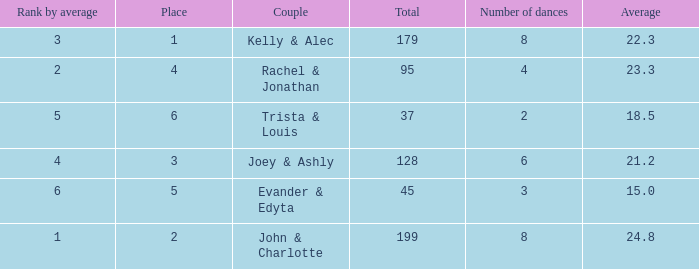What is the highest average that has 6 dances and a total of over 128? None. 